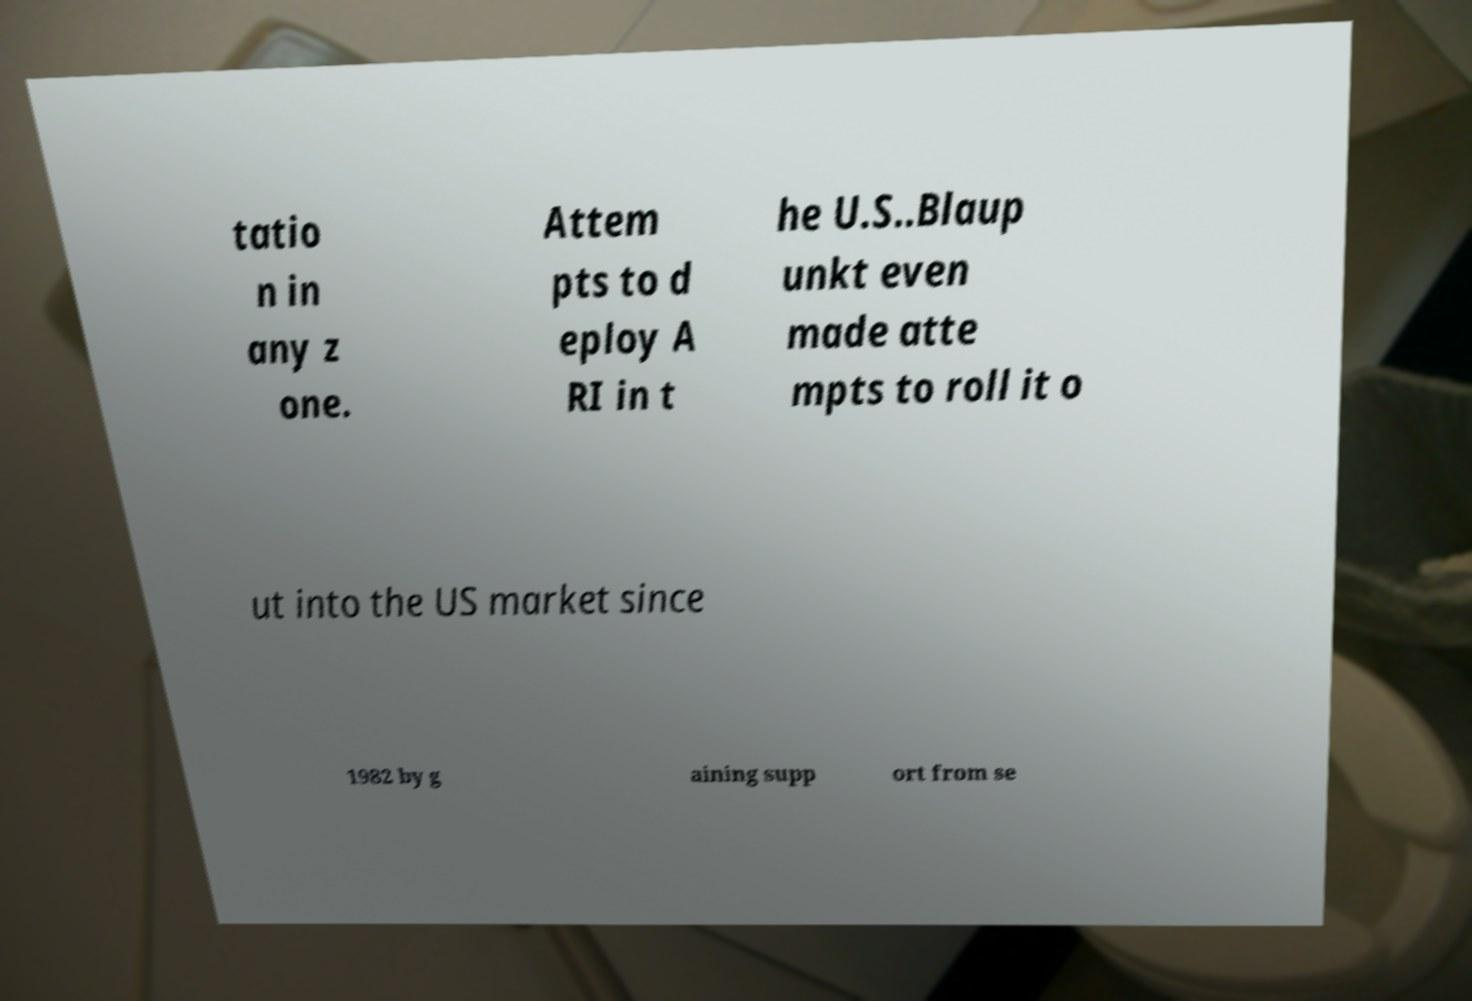There's text embedded in this image that I need extracted. Can you transcribe it verbatim? tatio n in any z one. Attem pts to d eploy A RI in t he U.S..Blaup unkt even made atte mpts to roll it o ut into the US market since 1982 by g aining supp ort from se 